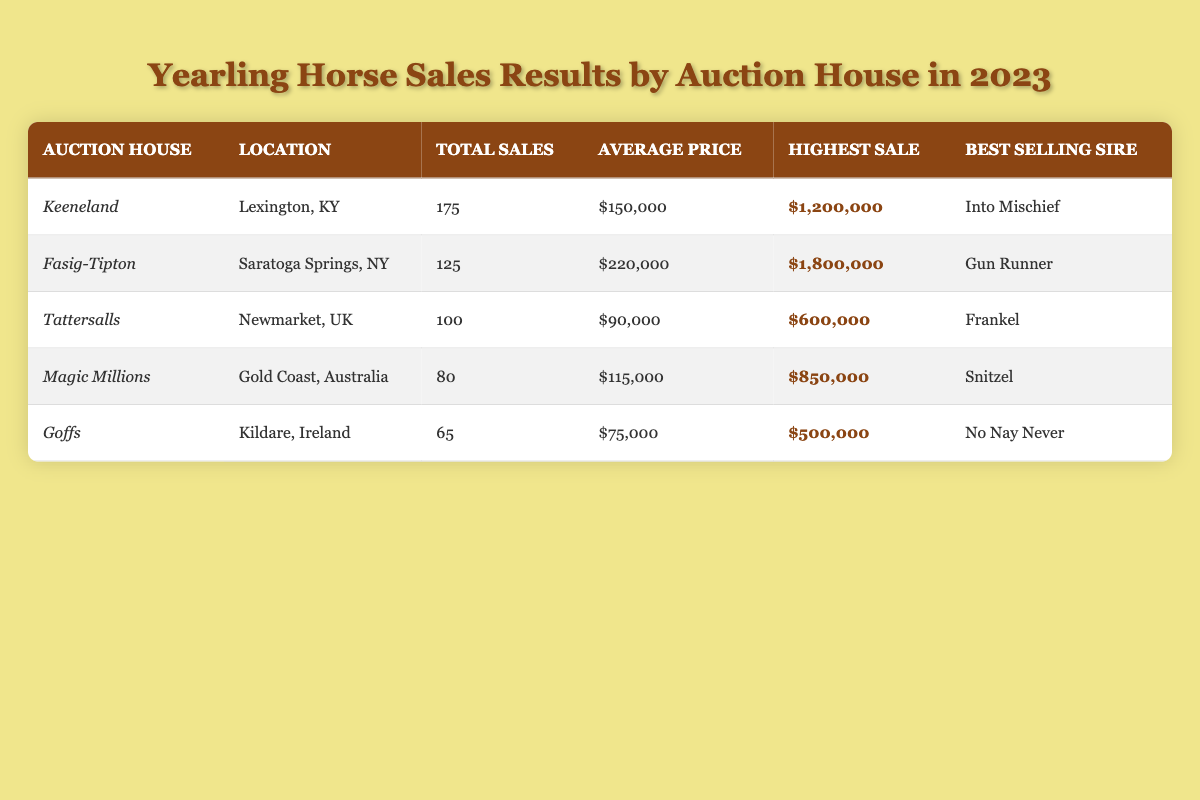What is the highest sale recorded at Fasig-Tipton? The table indicates that the highest sale at Fasig-Tipton is listed under the "Highest Sale" column. Checking that row shows the value is listed as $1,800,000.
Answer: 1,800,000 How many yearlings were sold at Keeneland? The table shows that the total sales at Keeneland are found in the "Total Sales" column. Looking at that row reveals the number is 175.
Answer: 175 Which auction house had the lowest average sale price? To find the lowest average sale price, compare the values in the "Average Price" column for each auction house. The lowest value is $75,000 at Goffs.
Answer: Goffs What is the total number of yearlings sold across all auction houses? To determine the total, sum the values in the "Total Sales" column for all houses: 175 + 125 + 100 + 80 + 65 = 645.
Answer: 645 Which sire had the highest average selling price and what was that price? First, we check the "Average Price" for each best-selling sire. Gun Runner at Fasig-Tipton has the highest average price of $220,000.
Answer: Gun Runner; 220,000 Was the highest sale at Keeneland greater than the highest sale at Magic Millions? The highest sale at Keeneland is $1,200,000 and at Magic Millions it's $850,000. Since $1,200,000 is greater than $850,000, the answer is yes.
Answer: Yes If we rank the auction houses by average sale price, which is in third place? After listing the average prices, they are: Fasig-Tipton ($220,000), Keeneland ($150,000), Tattersalls ($90,000), Magic Millions ($115,000), and Goffs ($75,000). The third highest is $115,000 for Magic Millions.
Answer: Magic Millions What percentage of total sales did Keene land account for? First, calculate total sales (645) and find Keeneland's total sales (175). The percentage is (175 / 645) * 100 = approximately 27.2%.
Answer: 27.2% Which auction house had a total of 100 or more yearlings sold? From the table, Keeneland (175), Fasig-Tipton (125), and Tattersalls (100) all fall into this category based on the "Total Sales" column.
Answer: Keeneland, Fasig-Tipton, Tattersalls What is the difference in highest sale value between Goffs and Keeneland? The highest sale for Goffs is $500,000, and for Keeneland it's $1,200,000. Subtracting gives $1,200,000 - $500,000 = $700,000.
Answer: 700,000 